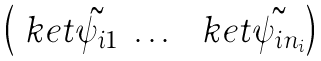Convert formula to latex. <formula><loc_0><loc_0><loc_500><loc_500>\begin{pmatrix} \ k e t { \tilde { \psi _ { i 1 } } } & \dots & \ k e t { \tilde { \psi _ { i n _ { i } } } } \end{pmatrix}</formula> 